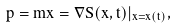<formula> <loc_0><loc_0><loc_500><loc_500>p = m \dot { x } = \nabla S ( x , t ) | _ { x = x ( t ) } ,</formula> 